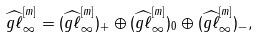Convert formula to latex. <formula><loc_0><loc_0><loc_500><loc_500>\widehat { g \ell } ^ { [ m ] } _ { \infty } = ( \widehat { g \ell } ^ { [ m ] } _ { \infty } ) _ { + } \oplus ( \widehat { g \ell } ^ { [ m ] } _ { \infty } ) _ { 0 } \oplus ( \widehat { g \ell } ^ { [ m ] } _ { \infty } ) _ { - } ,</formula> 